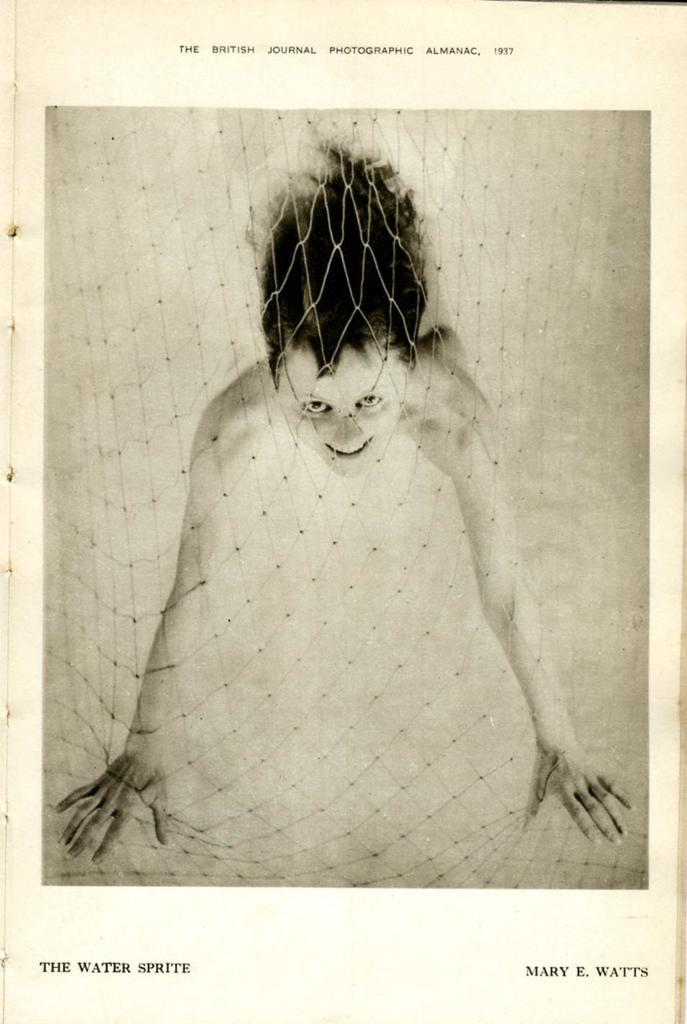Who or what is present in the image? There is a person in the image. What is in front of the person? There is a net in front of the person. What color is the background of the image? The background of the image is in cream color. Can you see a tiger in the image? No, there is no tiger present in the image. What type of spot is visible on the person's clothing in the image? There is no spot visible on the person's clothing in the image. 